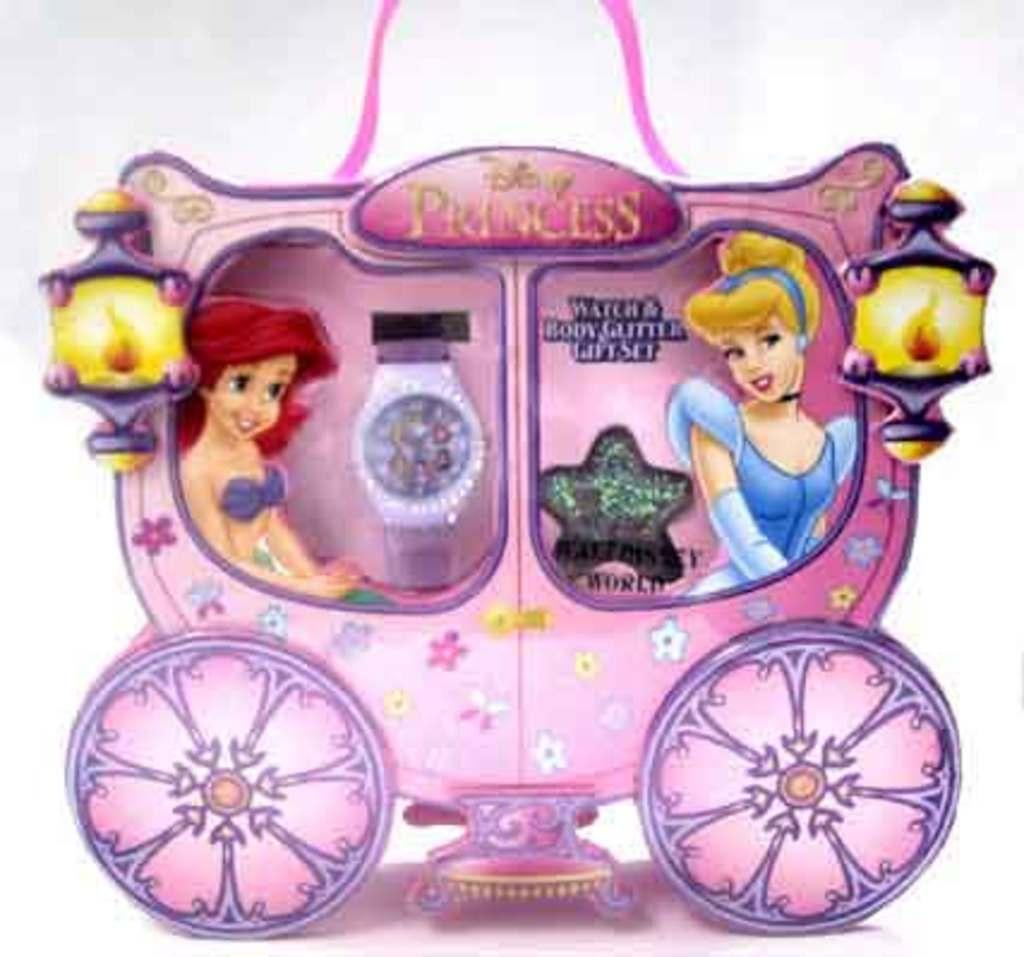<image>
Create a compact narrative representing the image presented. Hey child's gift set is colored pink and includes body glitter. 